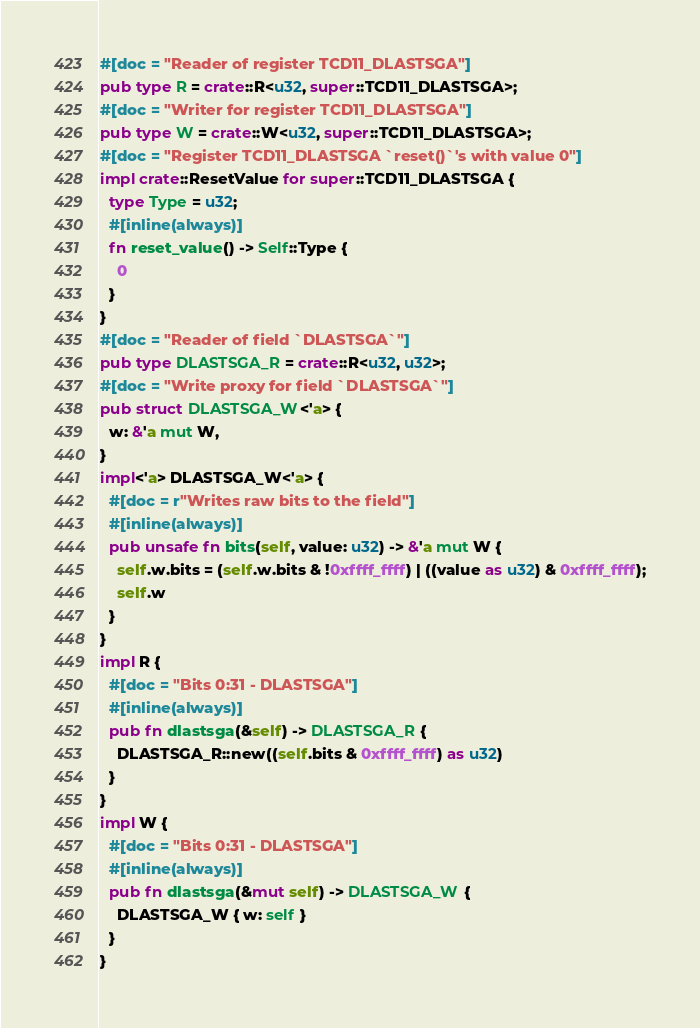Convert code to text. <code><loc_0><loc_0><loc_500><loc_500><_Rust_>#[doc = "Reader of register TCD11_DLASTSGA"]
pub type R = crate::R<u32, super::TCD11_DLASTSGA>;
#[doc = "Writer for register TCD11_DLASTSGA"]
pub type W = crate::W<u32, super::TCD11_DLASTSGA>;
#[doc = "Register TCD11_DLASTSGA `reset()`'s with value 0"]
impl crate::ResetValue for super::TCD11_DLASTSGA {
  type Type = u32;
  #[inline(always)]
  fn reset_value() -> Self::Type {
    0
  }
}
#[doc = "Reader of field `DLASTSGA`"]
pub type DLASTSGA_R = crate::R<u32, u32>;
#[doc = "Write proxy for field `DLASTSGA`"]
pub struct DLASTSGA_W<'a> {
  w: &'a mut W,
}
impl<'a> DLASTSGA_W<'a> {
  #[doc = r"Writes raw bits to the field"]
  #[inline(always)]
  pub unsafe fn bits(self, value: u32) -> &'a mut W {
    self.w.bits = (self.w.bits & !0xffff_ffff) | ((value as u32) & 0xffff_ffff);
    self.w
  }
}
impl R {
  #[doc = "Bits 0:31 - DLASTSGA"]
  #[inline(always)]
  pub fn dlastsga(&self) -> DLASTSGA_R {
    DLASTSGA_R::new((self.bits & 0xffff_ffff) as u32)
  }
}
impl W {
  #[doc = "Bits 0:31 - DLASTSGA"]
  #[inline(always)]
  pub fn dlastsga(&mut self) -> DLASTSGA_W {
    DLASTSGA_W { w: self }
  }
}
</code> 